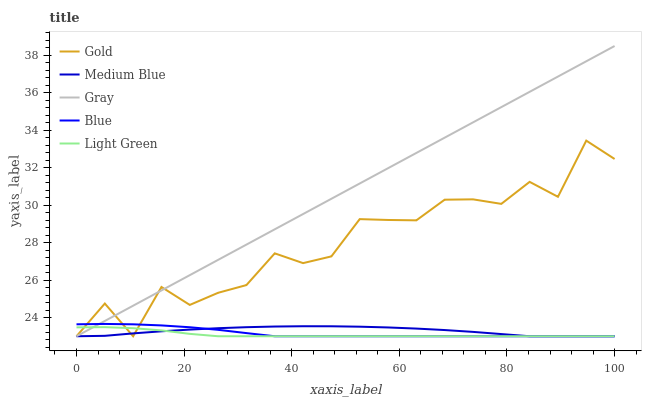Does Light Green have the minimum area under the curve?
Answer yes or no. Yes. Does Gray have the maximum area under the curve?
Answer yes or no. Yes. Does Medium Blue have the minimum area under the curve?
Answer yes or no. No. Does Medium Blue have the maximum area under the curve?
Answer yes or no. No. Is Gray the smoothest?
Answer yes or no. Yes. Is Gold the roughest?
Answer yes or no. Yes. Is Medium Blue the smoothest?
Answer yes or no. No. Is Medium Blue the roughest?
Answer yes or no. No. Does Gray have the highest value?
Answer yes or no. Yes. Does Medium Blue have the highest value?
Answer yes or no. No. Does Blue intersect Gold?
Answer yes or no. Yes. Is Blue less than Gold?
Answer yes or no. No. Is Blue greater than Gold?
Answer yes or no. No. 